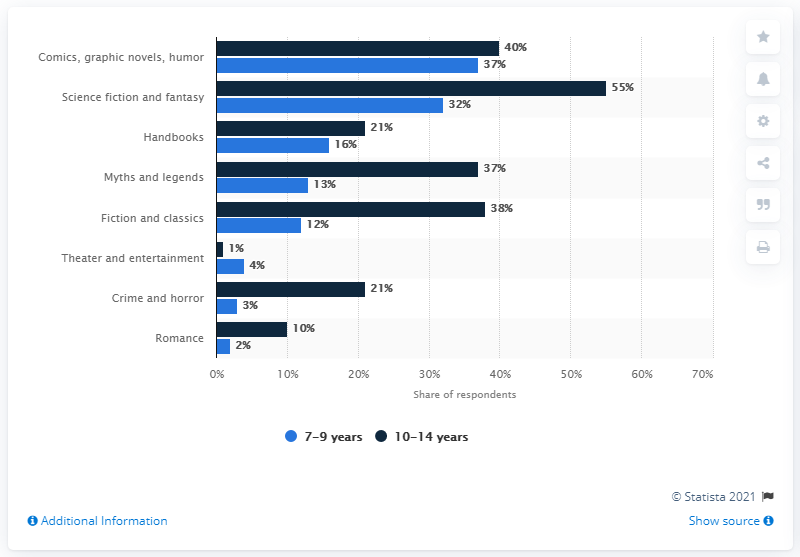Highlight a few significant elements in this photo. The difference between the shortest light blue bar and the tallest blue bar is -53. According to a survey conducted in 2018, children in Italy showed a strong preference for books in the comics, graphic novels, and humor genre, with the highest percentage of preference among children aged 9-10 and 11-12. 